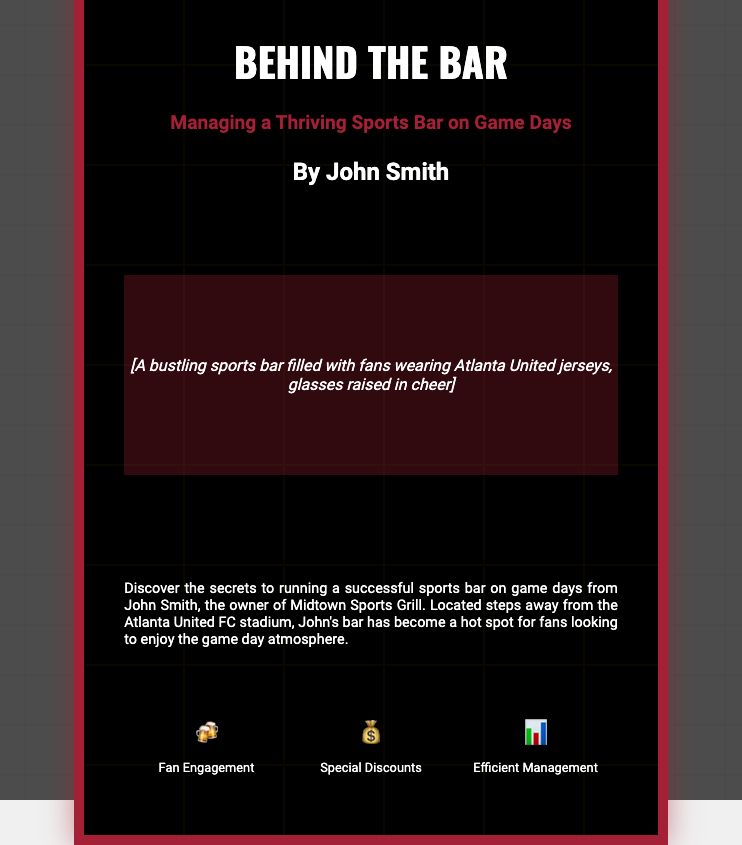What is the title of the book? The title is prominently displayed on the cover.
Answer: Behind the Bar Who is the author of the book? The author's name is listed beneath the title.
Answer: John Smith What is the subtitle of the book? The subtitle provides additional context about the book's focus.
Answer: Managing a Thriving Sports Bar on Game Days What type of atmosphere is depicted in the image placeholder? The description of the image in the placeholder indicates the lively scene.
Answer: A bustling sports bar filled with fans wearing Atlanta United jerseys What location is mentioned in the blurb? The blurb references a specific location significant to the author's experience.
Answer: Midtown Sports Grill What is one of the highlights mentioned on the cover? The cover features three highlights, one of which is presented visually.
Answer: Fan Engagement How many highlights are listed on the cover? The highlights section includes a specific number of items.
Answer: Three What is the primary audience for this book likely to be? The subject matter hints at who would be most interested in reading it.
Answer: Sports bar owners What kind of discounts are mentioned in the highlights? The highlights provide insights into promotional strategies relevant to the audience.
Answer: Special Discounts 